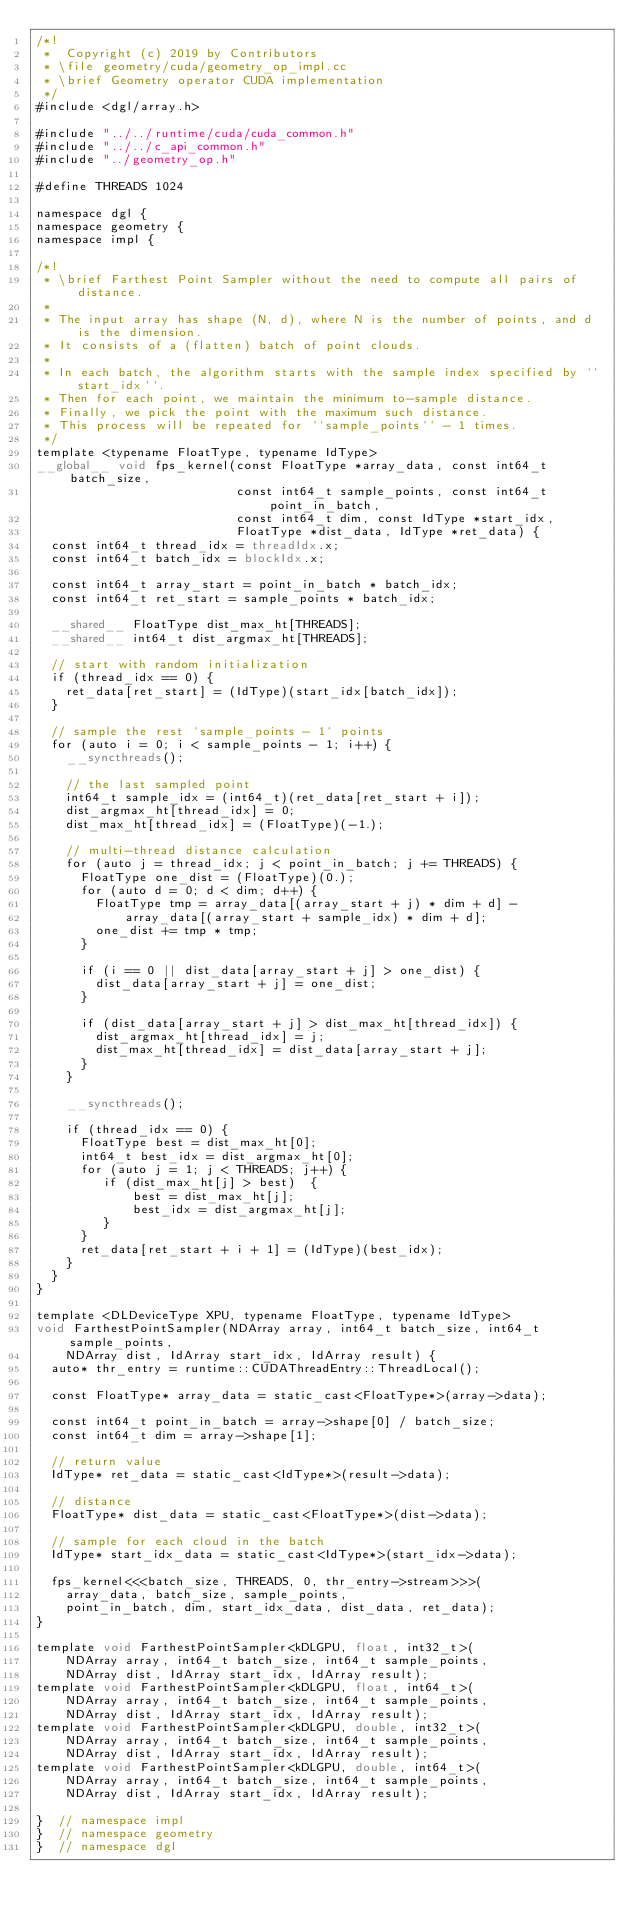<code> <loc_0><loc_0><loc_500><loc_500><_Cuda_>/*!
 *  Copyright (c) 2019 by Contributors
 * \file geometry/cuda/geometry_op_impl.cc
 * \brief Geometry operator CUDA implementation
 */
#include <dgl/array.h>

#include "../../runtime/cuda/cuda_common.h"
#include "../../c_api_common.h"
#include "../geometry_op.h"

#define THREADS 1024

namespace dgl {
namespace geometry {
namespace impl {

/*!
 * \brief Farthest Point Sampler without the need to compute all pairs of distance.
 * 
 * The input array has shape (N, d), where N is the number of points, and d is the dimension.
 * It consists of a (flatten) batch of point clouds.
 *
 * In each batch, the algorithm starts with the sample index specified by ``start_idx``.
 * Then for each point, we maintain the minimum to-sample distance.
 * Finally, we pick the point with the maximum such distance.
 * This process will be repeated for ``sample_points`` - 1 times.
 */
template <typename FloatType, typename IdType>
__global__ void fps_kernel(const FloatType *array_data, const int64_t batch_size,
                           const int64_t sample_points, const int64_t point_in_batch,
                           const int64_t dim, const IdType *start_idx,
                           FloatType *dist_data, IdType *ret_data) {
  const int64_t thread_idx = threadIdx.x;
  const int64_t batch_idx = blockIdx.x;

  const int64_t array_start = point_in_batch * batch_idx;
  const int64_t ret_start = sample_points * batch_idx;

  __shared__ FloatType dist_max_ht[THREADS];
  __shared__ int64_t dist_argmax_ht[THREADS];

  // start with random initialization
  if (thread_idx == 0) {
    ret_data[ret_start] = (IdType)(start_idx[batch_idx]);
  }

  // sample the rest `sample_points - 1` points
  for (auto i = 0; i < sample_points - 1; i++) {
    __syncthreads();

    // the last sampled point
    int64_t sample_idx = (int64_t)(ret_data[ret_start + i]);
    dist_argmax_ht[thread_idx] = 0;
    dist_max_ht[thread_idx] = (FloatType)(-1.);

    // multi-thread distance calculation
    for (auto j = thread_idx; j < point_in_batch; j += THREADS) {
      FloatType one_dist = (FloatType)(0.);
      for (auto d = 0; d < dim; d++) {
        FloatType tmp = array_data[(array_start + j) * dim + d] -
            array_data[(array_start + sample_idx) * dim + d];
        one_dist += tmp * tmp;
      }

      if (i == 0 || dist_data[array_start + j] > one_dist) {
        dist_data[array_start + j] = one_dist;
      }

      if (dist_data[array_start + j] > dist_max_ht[thread_idx]) {
        dist_argmax_ht[thread_idx] = j;
        dist_max_ht[thread_idx] = dist_data[array_start + j];
      }
    }

    __syncthreads();

    if (thread_idx == 0) {
      FloatType best = dist_max_ht[0];
      int64_t best_idx = dist_argmax_ht[0];
      for (auto j = 1; j < THREADS; j++) {
         if (dist_max_ht[j] > best)  {
             best = dist_max_ht[j];
             best_idx = dist_argmax_ht[j];
         }
      }
      ret_data[ret_start + i + 1] = (IdType)(best_idx);
    }
  }
}

template <DLDeviceType XPU, typename FloatType, typename IdType>
void FarthestPointSampler(NDArray array, int64_t batch_size, int64_t sample_points,
    NDArray dist, IdArray start_idx, IdArray result) {
  auto* thr_entry = runtime::CUDAThreadEntry::ThreadLocal();

  const FloatType* array_data = static_cast<FloatType*>(array->data);

  const int64_t point_in_batch = array->shape[0] / batch_size;
  const int64_t dim = array->shape[1];

  // return value
  IdType* ret_data = static_cast<IdType*>(result->data);

  // distance
  FloatType* dist_data = static_cast<FloatType*>(dist->data);

  // sample for each cloud in the batch
  IdType* start_idx_data = static_cast<IdType*>(start_idx->data);

  fps_kernel<<<batch_size, THREADS, 0, thr_entry->stream>>>(
    array_data, batch_size, sample_points,
    point_in_batch, dim, start_idx_data, dist_data, ret_data);
}

template void FarthestPointSampler<kDLGPU, float, int32_t>(
    NDArray array, int64_t batch_size, int64_t sample_points,
    NDArray dist, IdArray start_idx, IdArray result);
template void FarthestPointSampler<kDLGPU, float, int64_t>(
    NDArray array, int64_t batch_size, int64_t sample_points,
    NDArray dist, IdArray start_idx, IdArray result);
template void FarthestPointSampler<kDLGPU, double, int32_t>(
    NDArray array, int64_t batch_size, int64_t sample_points,
    NDArray dist, IdArray start_idx, IdArray result);
template void FarthestPointSampler<kDLGPU, double, int64_t>(
    NDArray array, int64_t batch_size, int64_t sample_points,
    NDArray dist, IdArray start_idx, IdArray result);

}  // namespace impl
}  // namespace geometry
}  // namespace dgl
</code> 